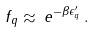<formula> <loc_0><loc_0><loc_500><loc_500>f _ { q } \approx \, e ^ { - \beta \epsilon ^ { \prime } _ { q } } \, .</formula> 